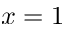<formula> <loc_0><loc_0><loc_500><loc_500>x = 1</formula> 